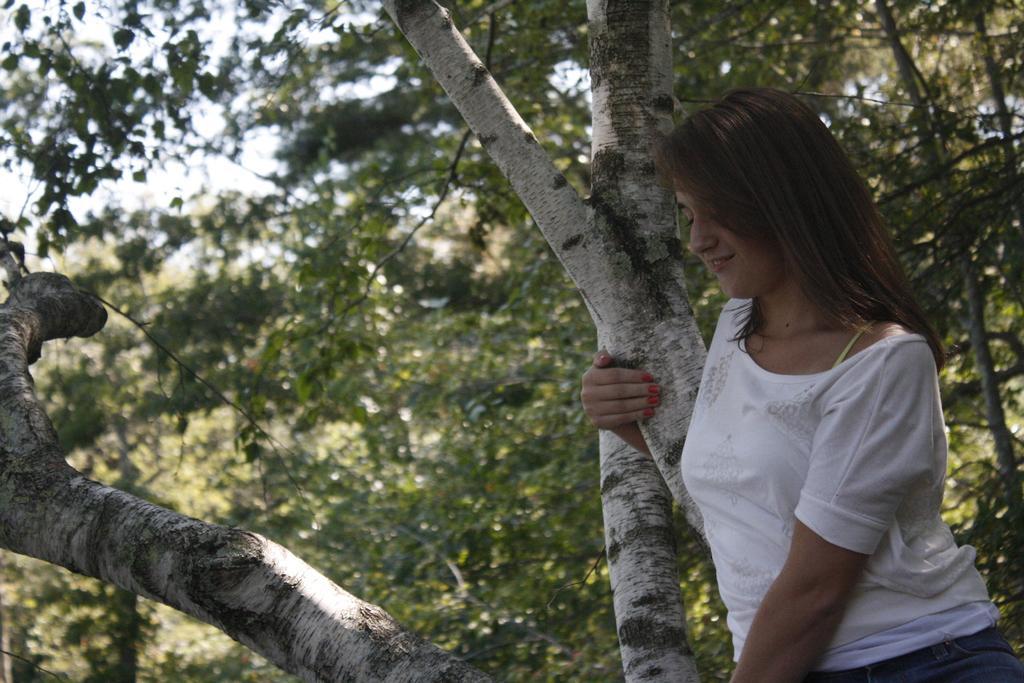How would you summarize this image in a sentence or two? In the image we can see there is a woman standing and she is holding tree trunk. Behind there are trees and background of the image is little blurred. 